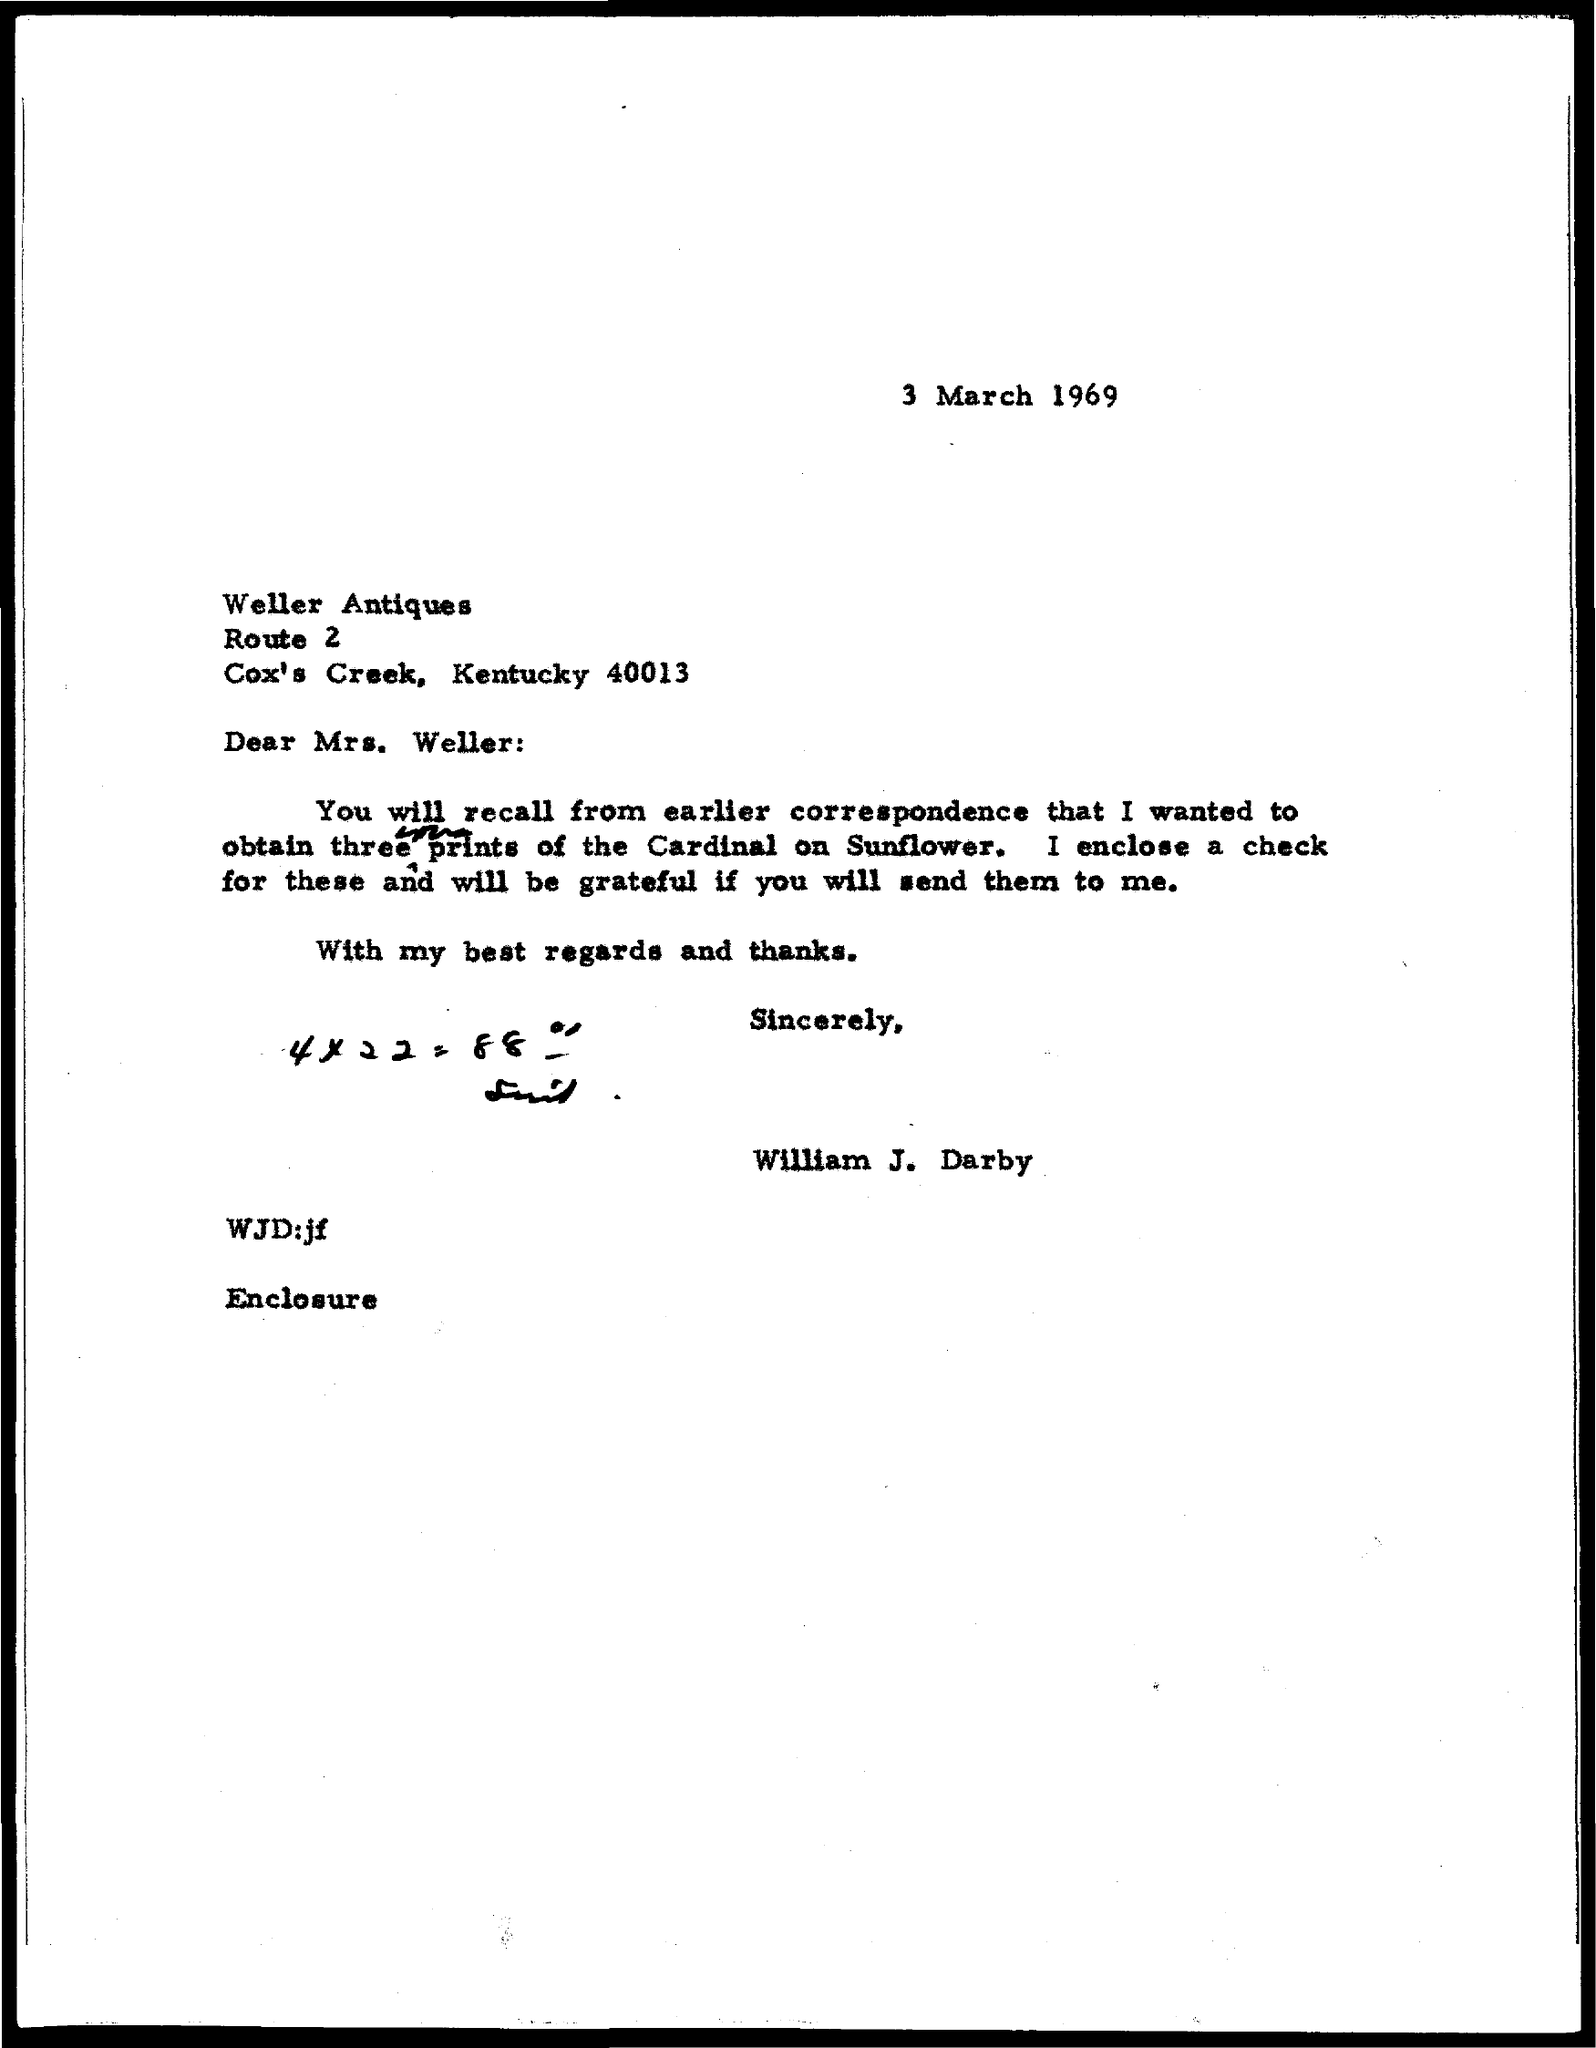Outline some significant characteristics in this image. The memorandum was dated March 3, 1969. The memorandum is addressed to WELLER ANTIQUES. 